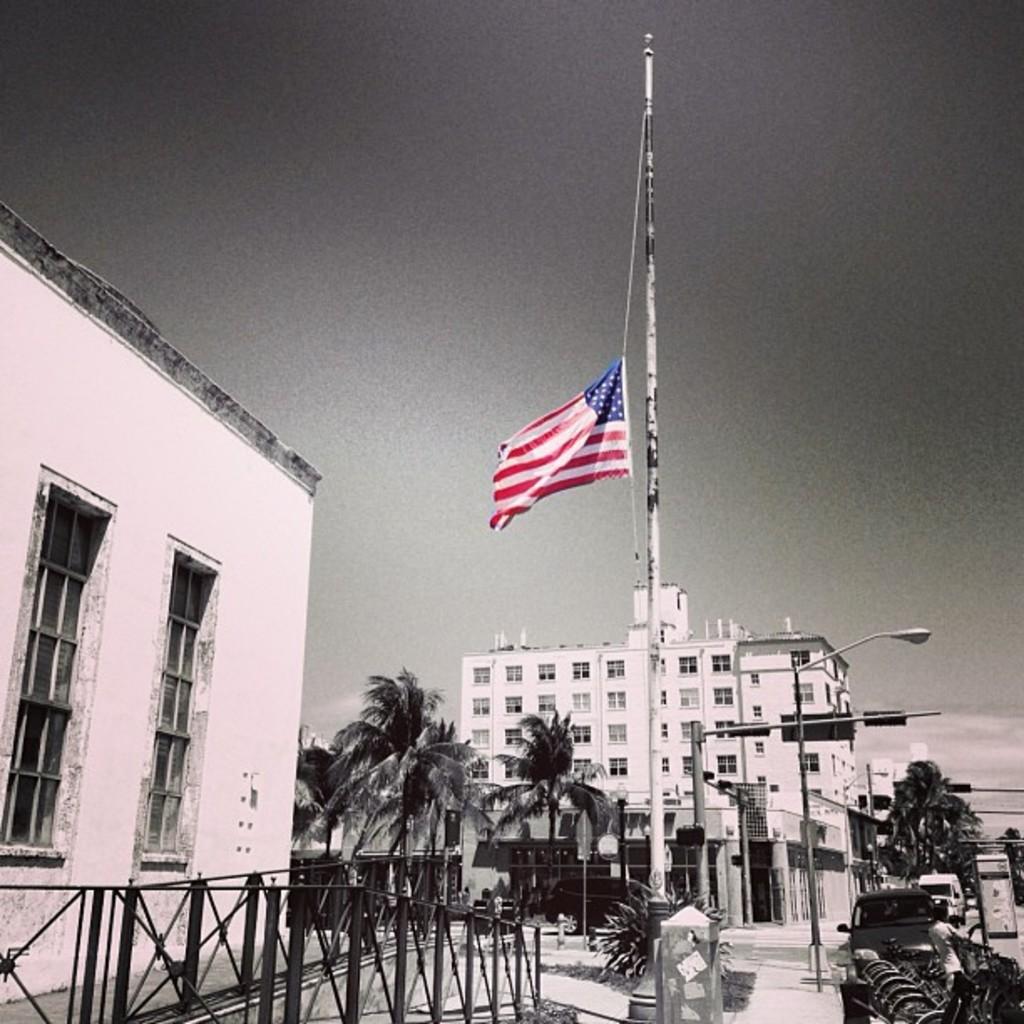Can you describe this image briefly? In this image I can see few trees, light poles. Background I can see few buildings, a flag in white, red and blue color and I can also see sky in gray color. 